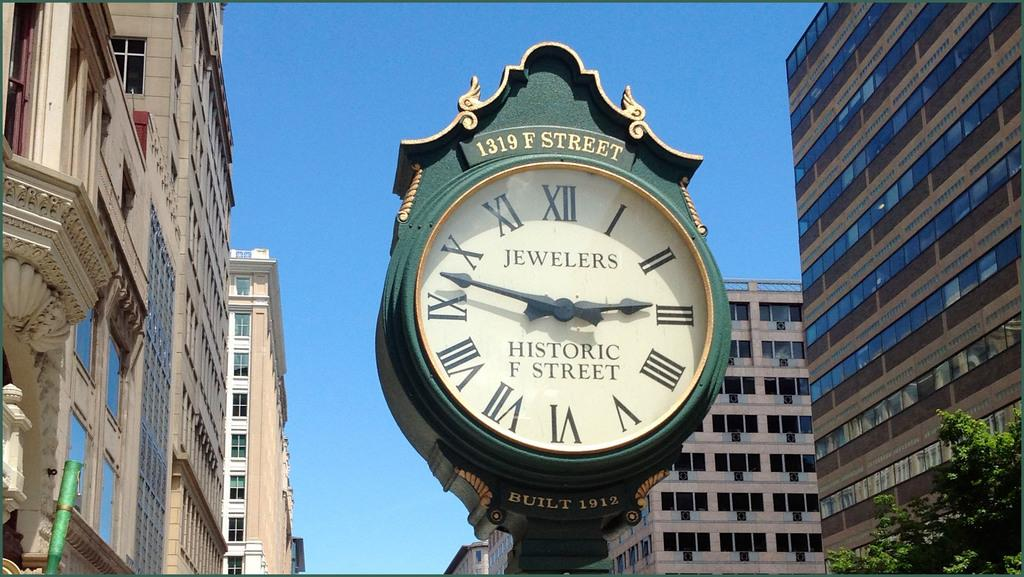Provide a one-sentence caption for the provided image. A clock at 1319 F street says "Jewelers" on it. 